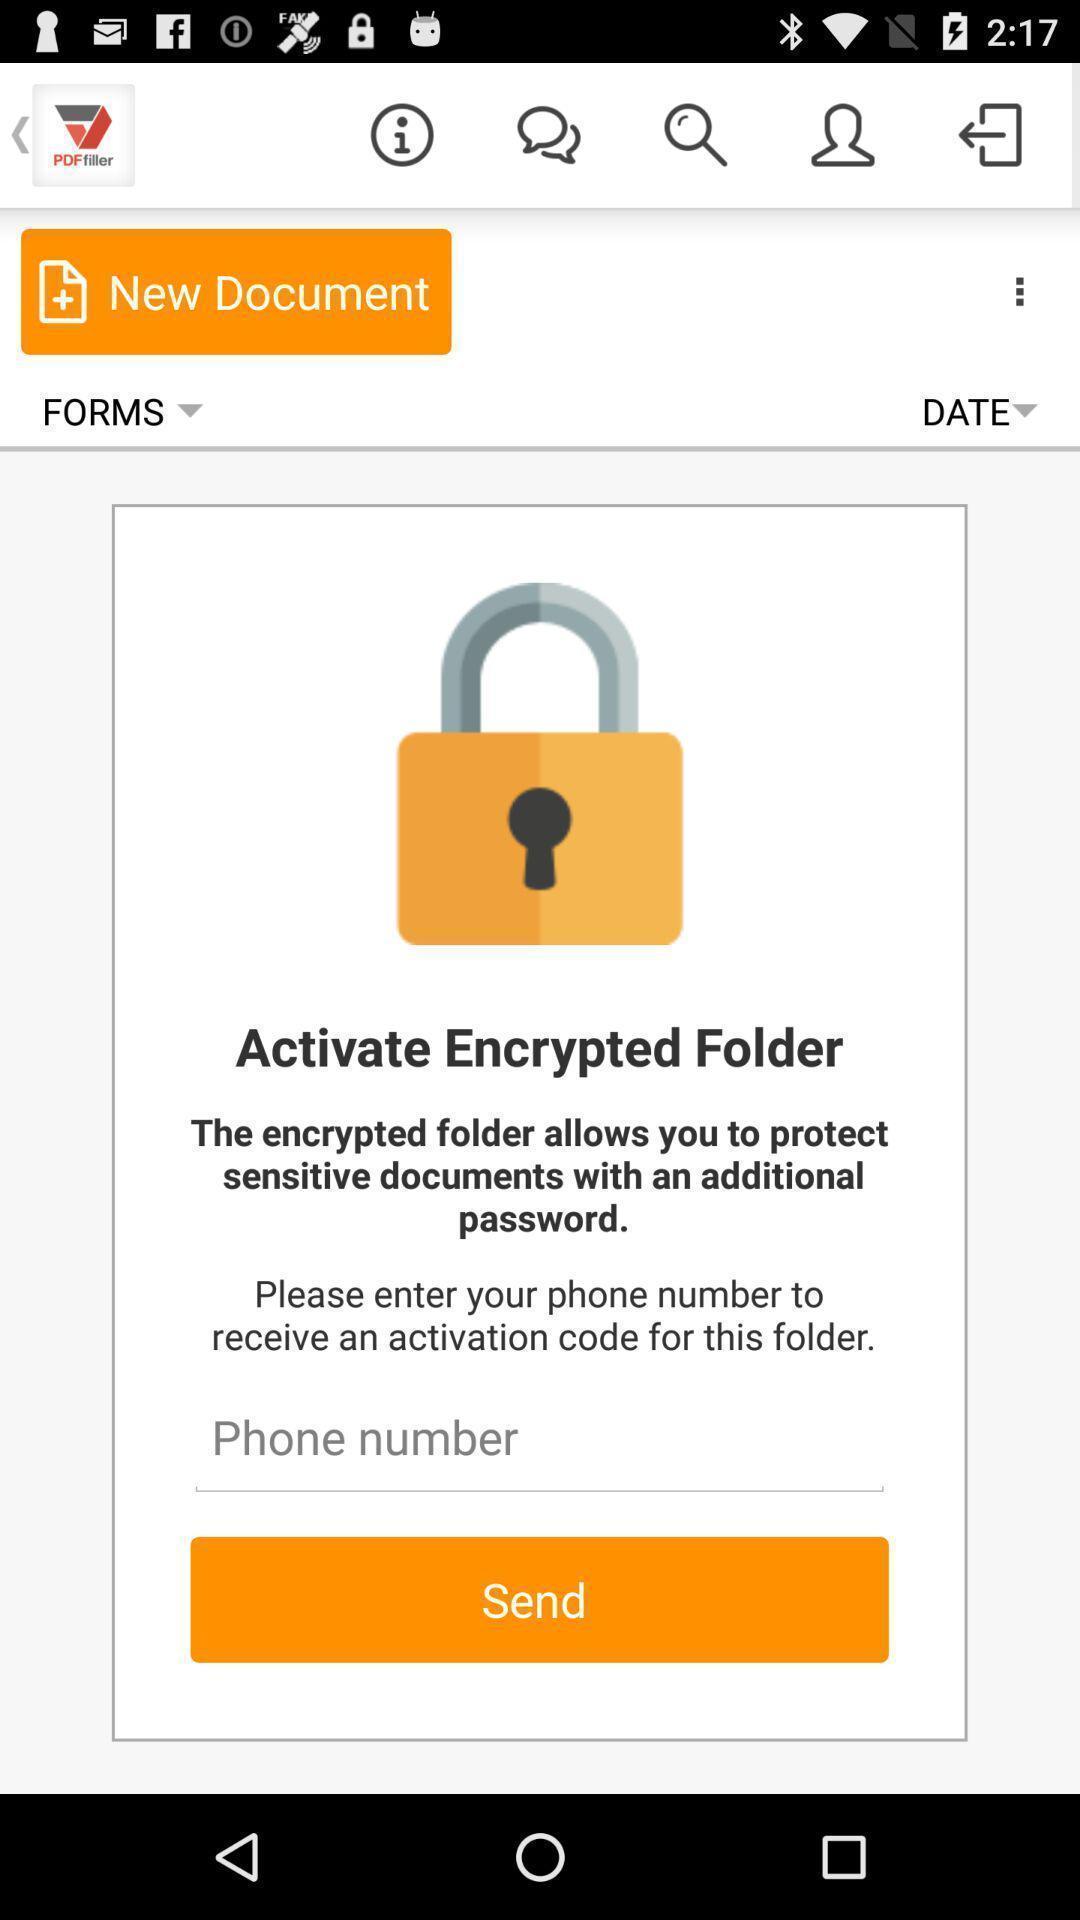Tell me what you see in this picture. Page of a pdf editor application. 